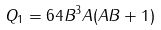<formula> <loc_0><loc_0><loc_500><loc_500>Q _ { 1 } = 6 4 B ^ { 3 } A ( A B + 1 )</formula> 